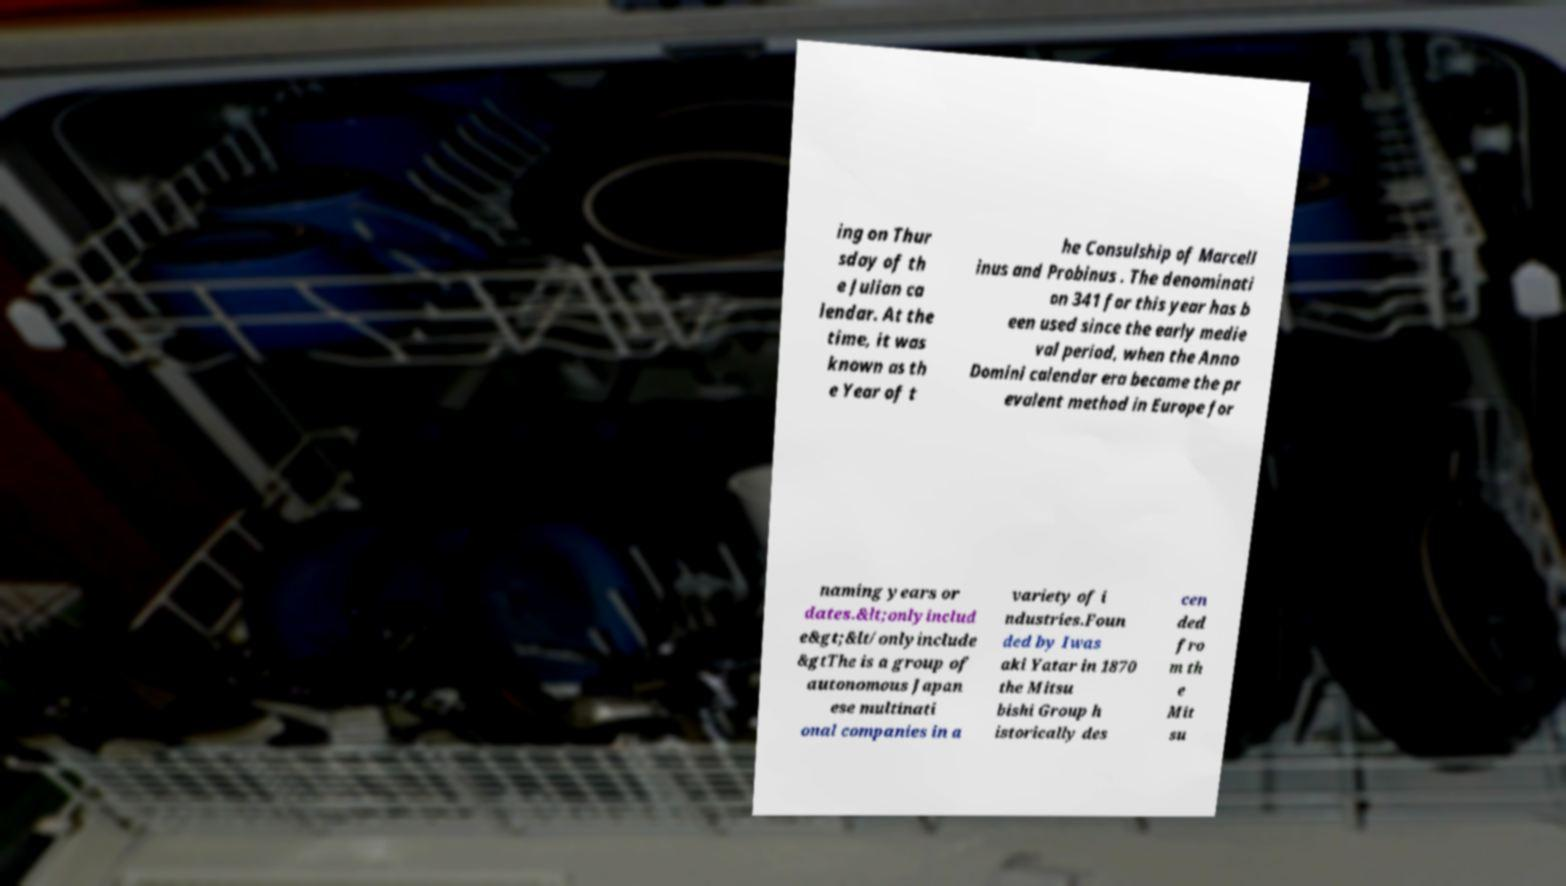Could you assist in decoding the text presented in this image and type it out clearly? ing on Thur sday of th e Julian ca lendar. At the time, it was known as th e Year of t he Consulship of Marcell inus and Probinus . The denominati on 341 for this year has b een used since the early medie val period, when the Anno Domini calendar era became the pr evalent method in Europe for naming years or dates.&lt;onlyinclud e&gt;&lt/onlyinclude &gtThe is a group of autonomous Japan ese multinati onal companies in a variety of i ndustries.Foun ded by Iwas aki Yatar in 1870 the Mitsu bishi Group h istorically des cen ded fro m th e Mit su 